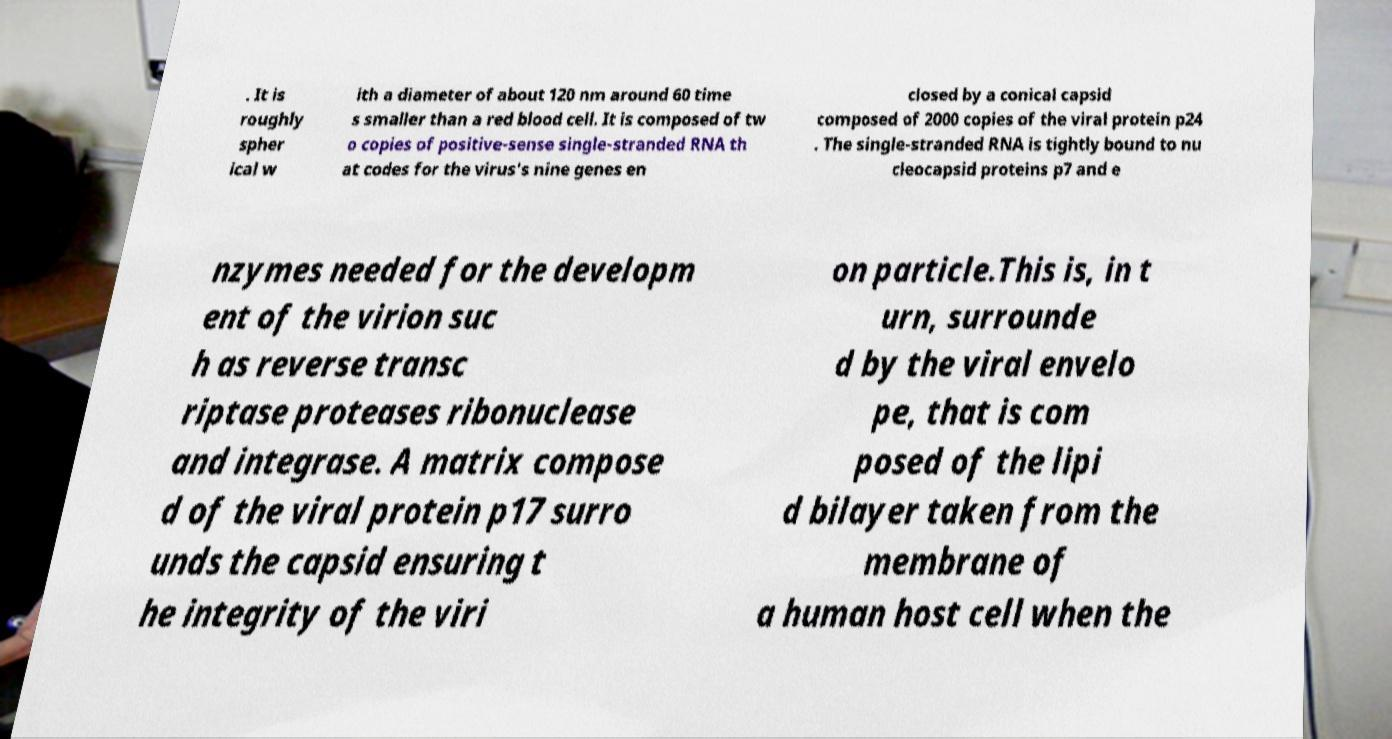Can you read and provide the text displayed in the image?This photo seems to have some interesting text. Can you extract and type it out for me? . It is roughly spher ical w ith a diameter of about 120 nm around 60 time s smaller than a red blood cell. It is composed of tw o copies of positive-sense single-stranded RNA th at codes for the virus's nine genes en closed by a conical capsid composed of 2000 copies of the viral protein p24 . The single-stranded RNA is tightly bound to nu cleocapsid proteins p7 and e nzymes needed for the developm ent of the virion suc h as reverse transc riptase proteases ribonuclease and integrase. A matrix compose d of the viral protein p17 surro unds the capsid ensuring t he integrity of the viri on particle.This is, in t urn, surrounde d by the viral envelo pe, that is com posed of the lipi d bilayer taken from the membrane of a human host cell when the 